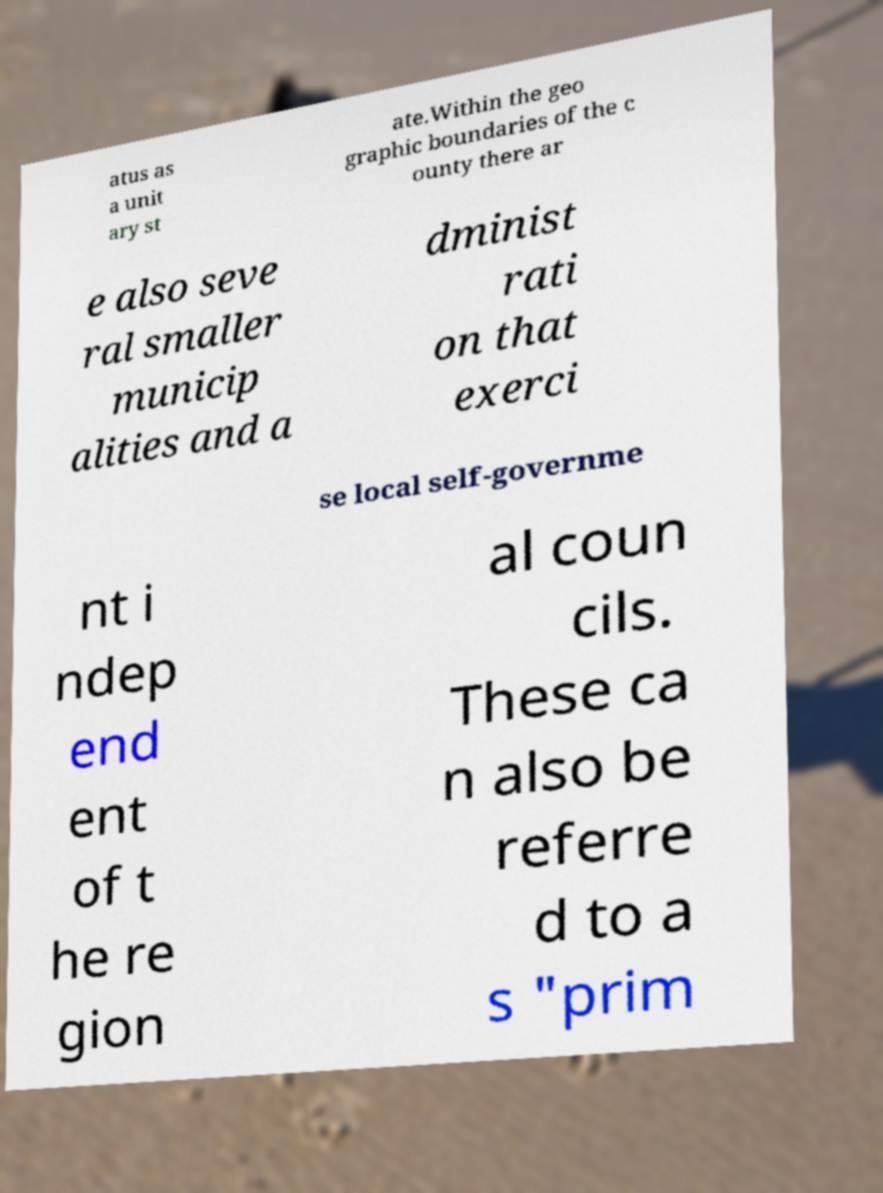Please read and relay the text visible in this image. What does it say? atus as a unit ary st ate.Within the geo graphic boundaries of the c ounty there ar e also seve ral smaller municip alities and a dminist rati on that exerci se local self-governme nt i ndep end ent of t he re gion al coun cils. These ca n also be referre d to a s "prim 